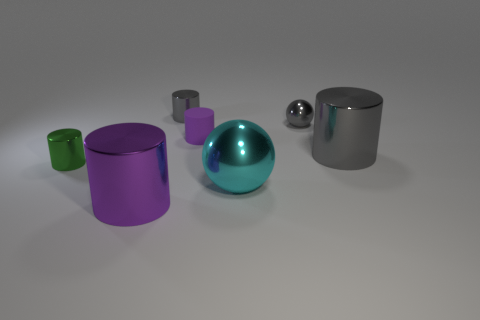Subtract all green cylinders. How many cylinders are left? 4 Subtract all green metal cylinders. How many cylinders are left? 4 Subtract 1 cylinders. How many cylinders are left? 4 Subtract all yellow cylinders. Subtract all purple blocks. How many cylinders are left? 5 Add 2 cyan objects. How many objects exist? 9 Subtract all spheres. How many objects are left? 5 Subtract all purple matte cylinders. Subtract all big objects. How many objects are left? 3 Add 1 small green objects. How many small green objects are left? 2 Add 2 purple metallic cylinders. How many purple metallic cylinders exist? 3 Subtract 0 purple balls. How many objects are left? 7 